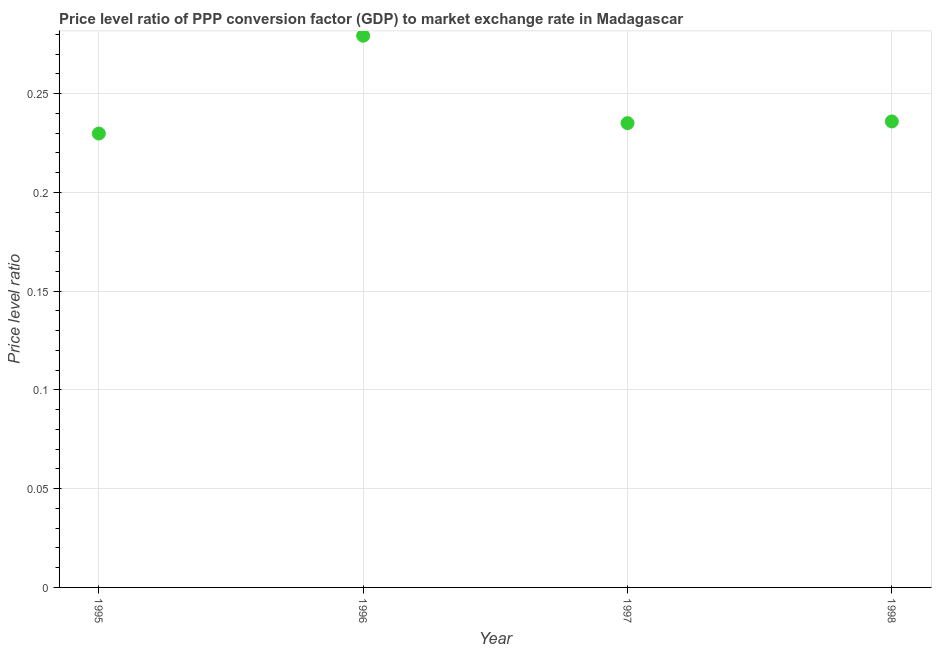What is the price level ratio in 1998?
Keep it short and to the point. 0.24. Across all years, what is the maximum price level ratio?
Ensure brevity in your answer.  0.28. Across all years, what is the minimum price level ratio?
Provide a succinct answer. 0.23. In which year was the price level ratio maximum?
Provide a succinct answer. 1996. What is the sum of the price level ratio?
Provide a short and direct response. 0.98. What is the difference between the price level ratio in 1995 and 1997?
Your response must be concise. -0.01. What is the average price level ratio per year?
Give a very brief answer. 0.24. What is the median price level ratio?
Your answer should be very brief. 0.24. Do a majority of the years between 1997 and 1996 (inclusive) have price level ratio greater than 0.01 ?
Ensure brevity in your answer.  No. What is the ratio of the price level ratio in 1995 to that in 1998?
Provide a short and direct response. 0.97. Is the difference between the price level ratio in 1996 and 1998 greater than the difference between any two years?
Offer a terse response. No. What is the difference between the highest and the second highest price level ratio?
Your answer should be very brief. 0.04. Is the sum of the price level ratio in 1995 and 1997 greater than the maximum price level ratio across all years?
Provide a short and direct response. Yes. What is the difference between the highest and the lowest price level ratio?
Provide a short and direct response. 0.05. Does the price level ratio monotonically increase over the years?
Provide a succinct answer. No. How many dotlines are there?
Keep it short and to the point. 1. How many years are there in the graph?
Your answer should be compact. 4. Does the graph contain any zero values?
Make the answer very short. No. What is the title of the graph?
Keep it short and to the point. Price level ratio of PPP conversion factor (GDP) to market exchange rate in Madagascar. What is the label or title of the Y-axis?
Provide a succinct answer. Price level ratio. What is the Price level ratio in 1995?
Ensure brevity in your answer.  0.23. What is the Price level ratio in 1996?
Make the answer very short. 0.28. What is the Price level ratio in 1997?
Offer a terse response. 0.24. What is the Price level ratio in 1998?
Offer a very short reply. 0.24. What is the difference between the Price level ratio in 1995 and 1996?
Offer a very short reply. -0.05. What is the difference between the Price level ratio in 1995 and 1997?
Offer a terse response. -0.01. What is the difference between the Price level ratio in 1995 and 1998?
Your response must be concise. -0.01. What is the difference between the Price level ratio in 1996 and 1997?
Provide a short and direct response. 0.04. What is the difference between the Price level ratio in 1996 and 1998?
Your response must be concise. 0.04. What is the difference between the Price level ratio in 1997 and 1998?
Your answer should be very brief. -0. What is the ratio of the Price level ratio in 1995 to that in 1996?
Offer a terse response. 0.82. What is the ratio of the Price level ratio in 1996 to that in 1997?
Your response must be concise. 1.19. What is the ratio of the Price level ratio in 1996 to that in 1998?
Provide a succinct answer. 1.18. What is the ratio of the Price level ratio in 1997 to that in 1998?
Ensure brevity in your answer.  1. 